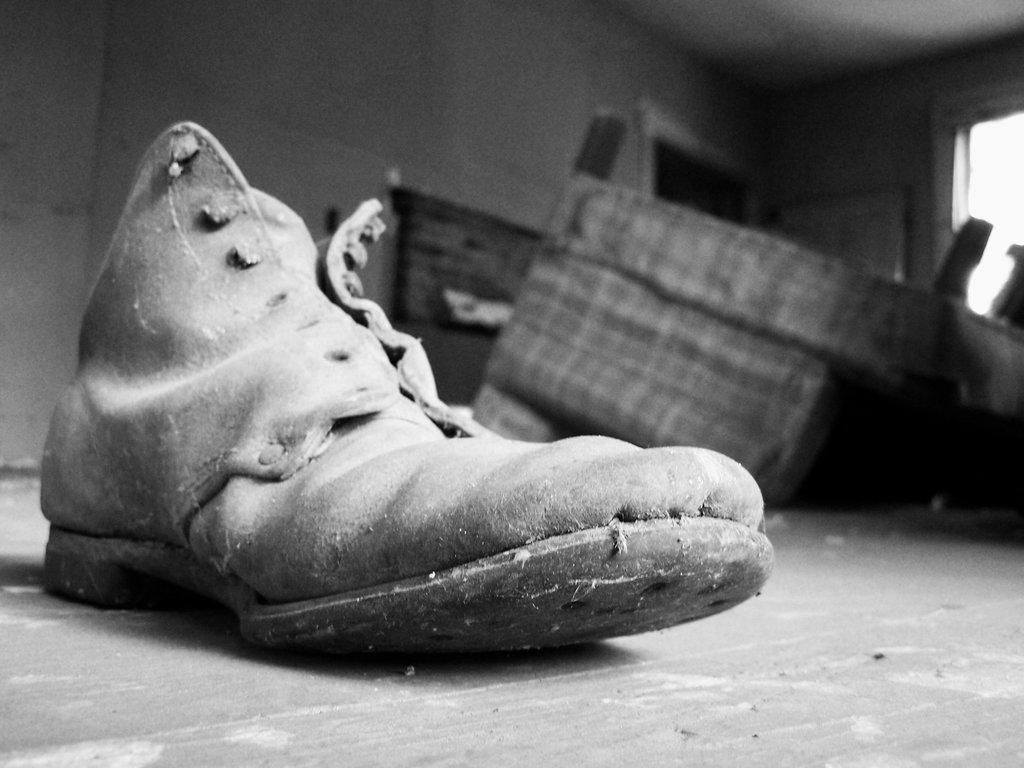What object is the main subject of the image? There is a shoe in the image. What is the color scheme of the image? The image is black and white in color. What type of church can be seen in the background of the image? There is no church present in the image; it only features a shoe in a black and white color scheme. 